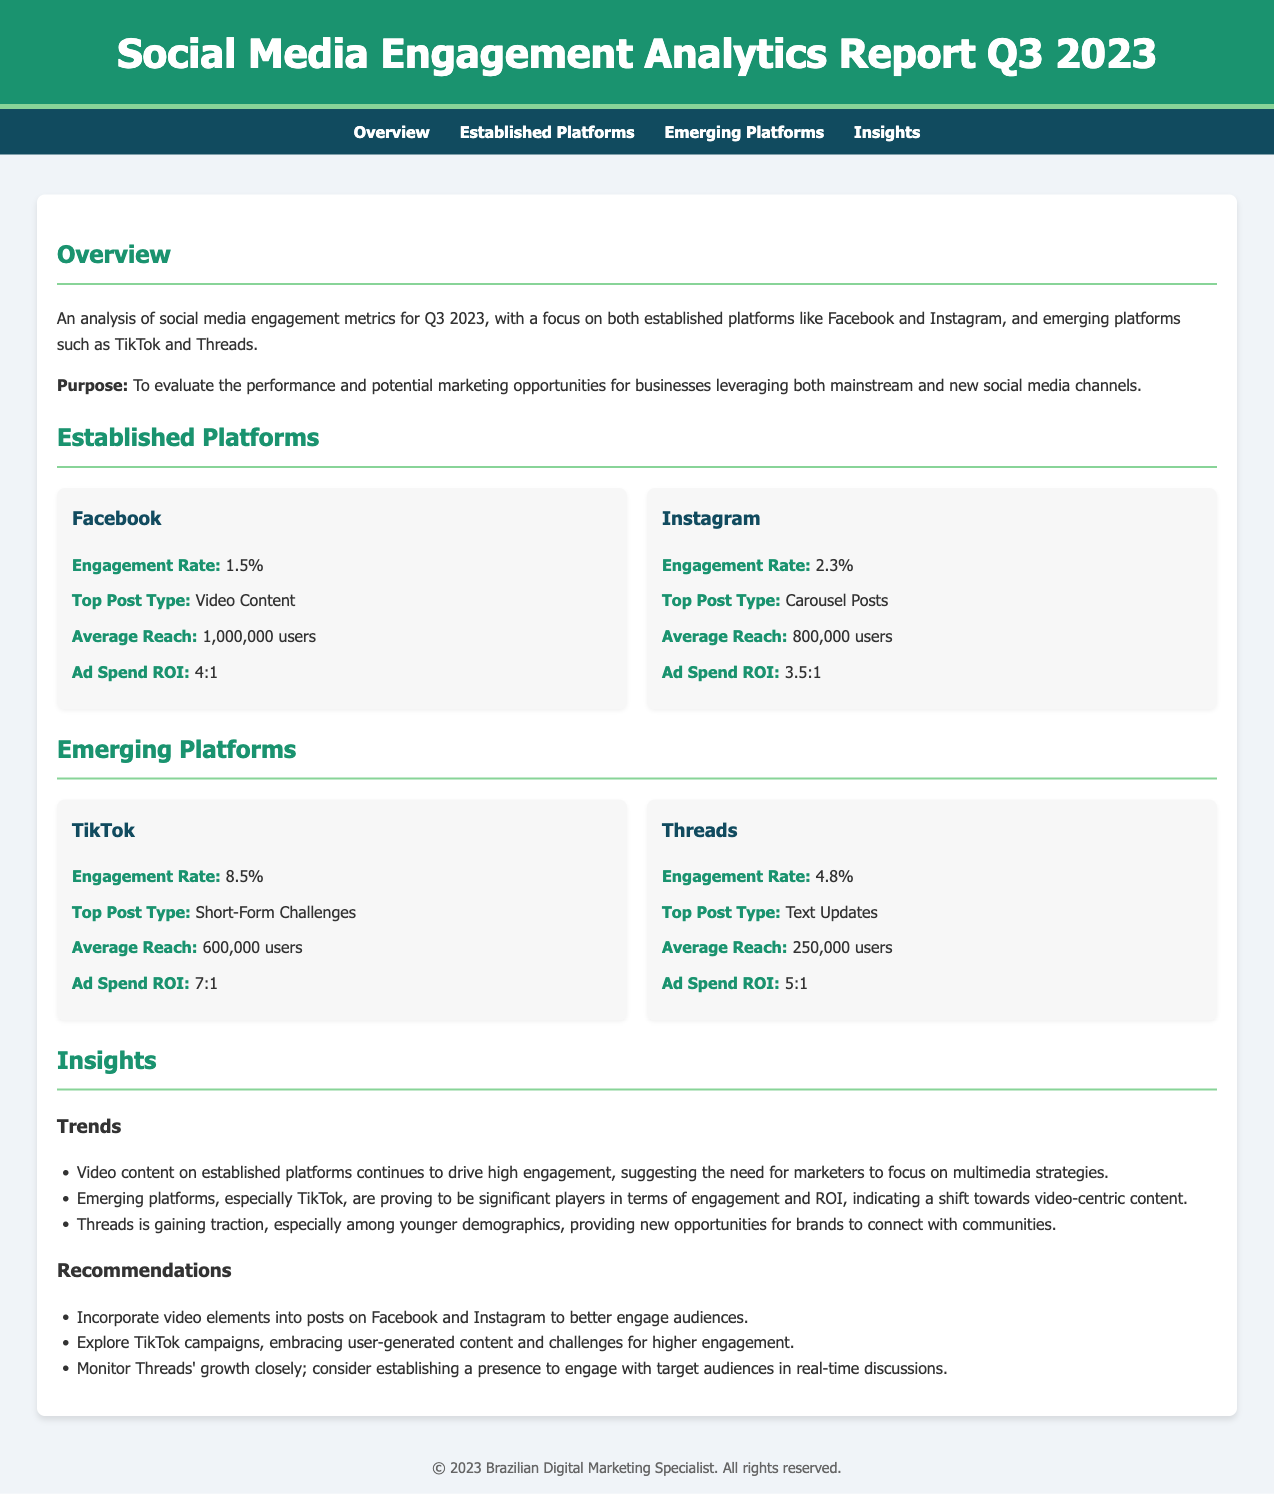What is the engagement rate for Facebook? The engagement rate for Facebook is specified in the document under the established platforms section.
Answer: 1.5% What is the average reach for Instagram? The average reach for Instagram is a performance metric noted in the established platforms section.
Answer: 800,000 users Which platform has the highest engagement rate? The engagement rates for the platforms are compared, with TikTok listed as having the highest rate.
Answer: 8.5% What type of posts generates the most engagement on Threads? The document mentions the top post type for Threads, providing insight into engagement strategies.
Answer: Text Updates What is the ad spend ROI for TikTok? The ad spend ROI is a performance metric outlined in the emerging platforms section, specifically for TikTok.
Answer: 7:1 What key trend is highlighted regarding video content? The insights section discusses trends related to engagement, particularly around video content across platforms.
Answer: High engagement How should brands respond to Threads' growth? The recommendations section suggests specific actions concerning emerging platforms, particularly Threads.
Answer: Establish a presence What is the focus of the Q3 2023 report? The report's focus is described in the overview section and emphasizes the analysis of social media engagement.
Answer: Performance and potential marketing opportunities What was the top post type for Facebook? The document provides details about the top post types for each platform, including Facebook.
Answer: Video Content 